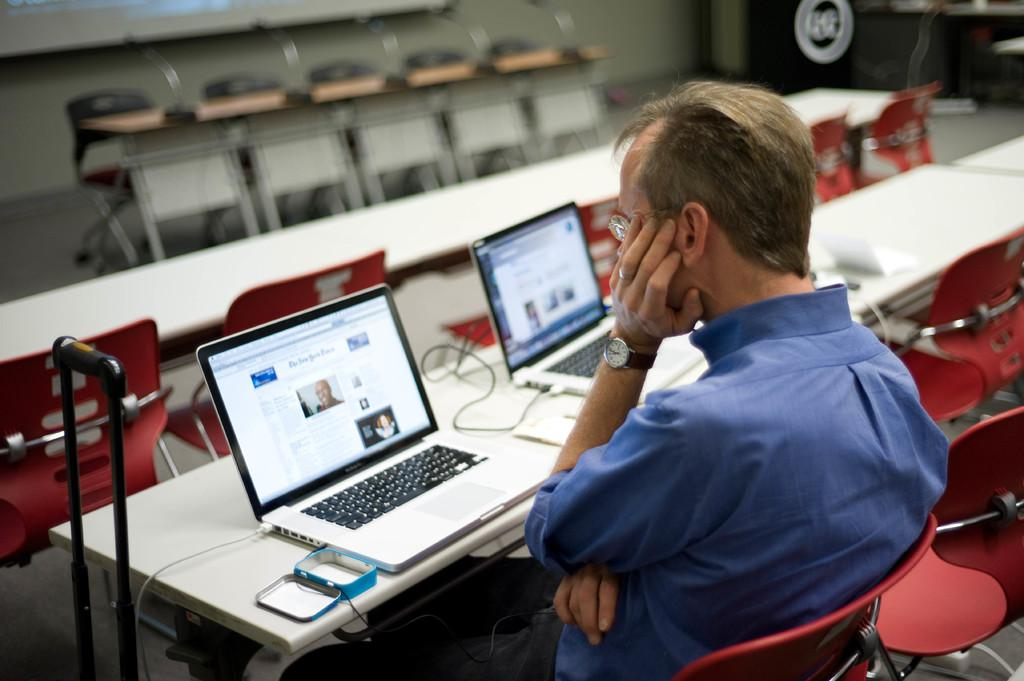What is the man in the image doing? The man is sitting on a chair in the image. What is in front of the man? There is a table in front of the man. What is on the table? There is a box and laptops on the table. How many balloons are floating above the man's head in the image? There are no balloons present in the image. Is there any corn visible on the table in the image? There is no corn visible on the table in the image. 